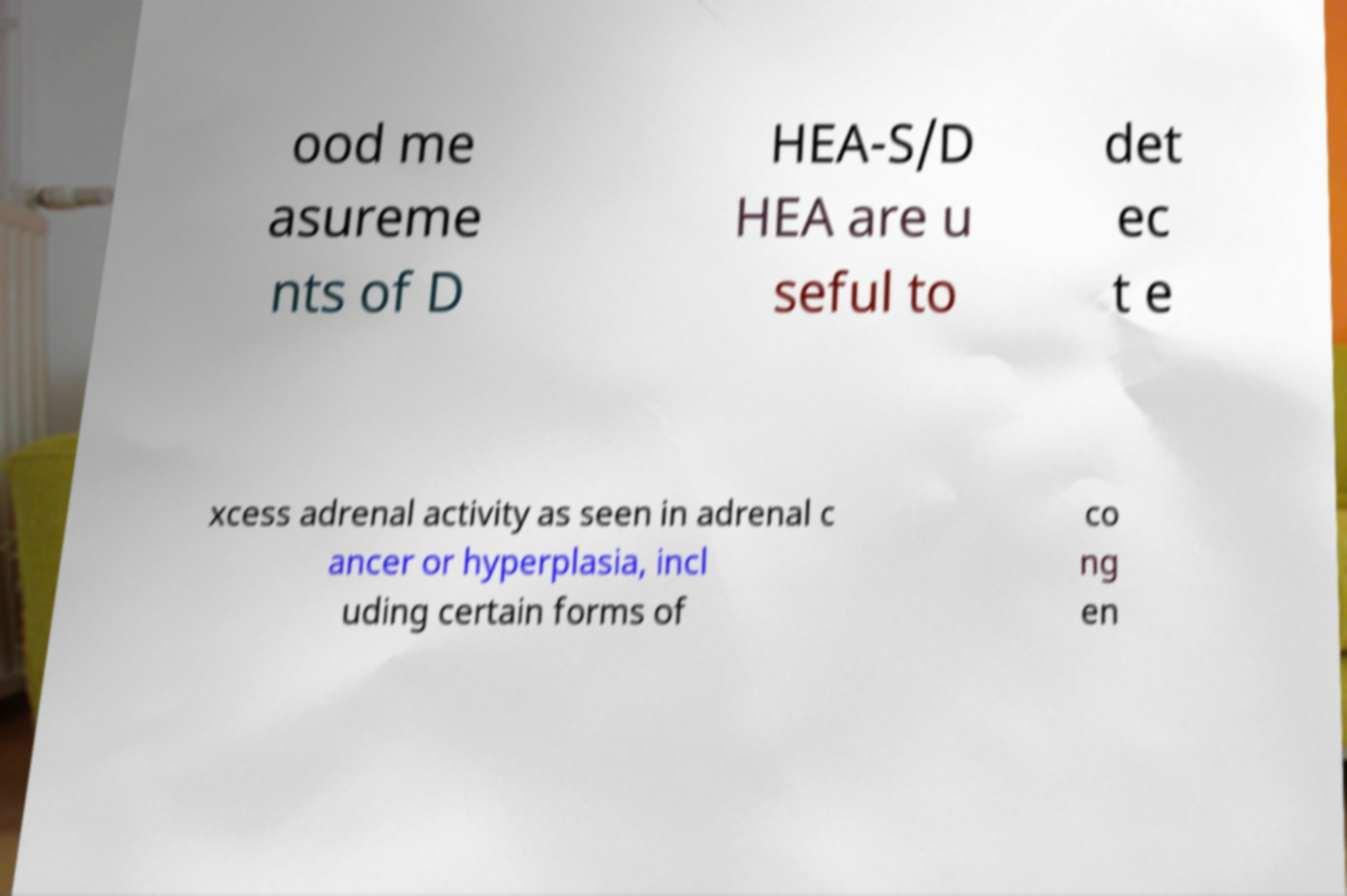Can you read and provide the text displayed in the image?This photo seems to have some interesting text. Can you extract and type it out for me? ood me asureme nts of D HEA-S/D HEA are u seful to det ec t e xcess adrenal activity as seen in adrenal c ancer or hyperplasia, incl uding certain forms of co ng en 